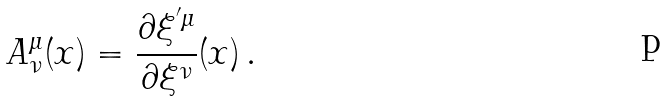Convert formula to latex. <formula><loc_0><loc_0><loc_500><loc_500>A ^ { \mu } _ { \nu } ( x ) = \frac { \partial \xi ^ { ^ { \prime } \mu } } { \partial \xi ^ { \nu } } ( x ) \, .</formula> 